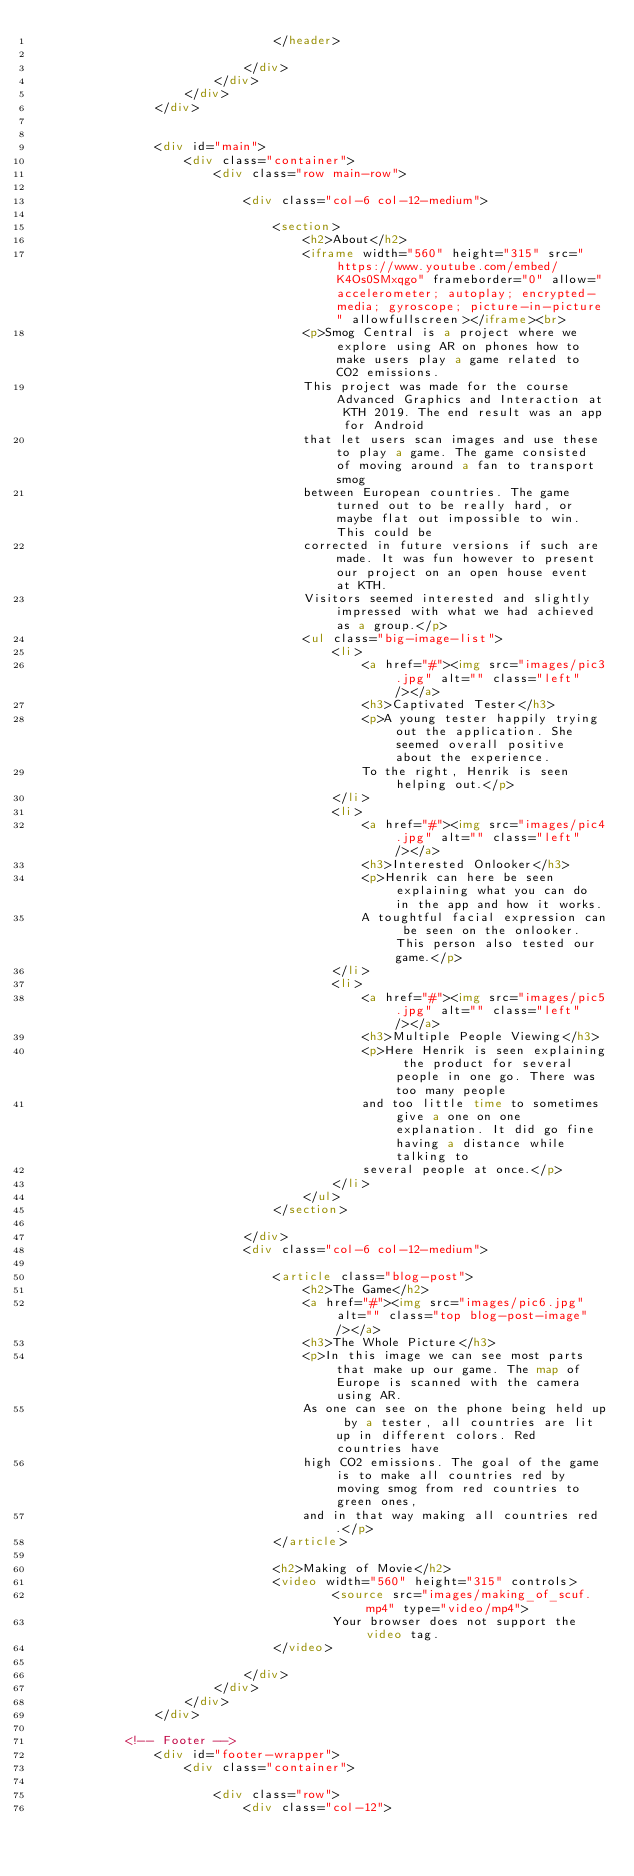Convert code to text. <code><loc_0><loc_0><loc_500><loc_500><_HTML_>								</header>

							</div>
						</div>
					</div>
				</div>


				<div id="main">
					<div class="container">
						<div class="row main-row">

							<div class="col-6 col-12-medium">

								<section>
									<h2>About</h2>
									<iframe width="560" height="315" src="https://www.youtube.com/embed/K4Os0SMxqgo" frameborder="0" allow="accelerometer; autoplay; encrypted-media; gyroscope; picture-in-picture" allowfullscreen></iframe><br>
									<p>Smog Central is a project where we explore using AR on phones how to make users play a game related to CO2 emissions.
									This project was made for the course Advanced Graphics and Interaction at KTH 2019. The end result was an app for Android
									that let users scan images and use these to play a game. The game consisted of moving around a fan to transport smog
									between European countries. The game turned out to be really hard, or maybe flat out impossible to win. This could be
									corrected in future versions if such are made. It was fun however to present our project on an open house event at KTH.
									Visitors seemed interested and slightly impressed with what we had achieved as a group.</p>
									<ul class="big-image-list">
										<li>
											<a href="#"><img src="images/pic3.jpg" alt="" class="left" /></a>
											<h3>Captivated Tester</h3>
											<p>A young tester happily trying out the application. She seemed overall positive about the experience.
											To the right, Henrik is seen helping out.</p>
										</li>
										<li>
											<a href="#"><img src="images/pic4.jpg" alt="" class="left" /></a>
											<h3>Interested Onlooker</h3>
											<p>Henrik can here be seen explaining what you can do in the app and how it works.
											A toughtful facial expression can be seen on the onlooker. This person also tested our game.</p>
										</li>
										<li>
											<a href="#"><img src="images/pic5.jpg" alt="" class="left" /></a>
											<h3>Multiple People Viewing</h3>
											<p>Here Henrik is seen explaining the product for several people in one go. There was too many people
											and too little time to sometimes give a one on one explanation. It did go fine having a distance while talking to
											several people at once.</p>
										</li>
									</ul>
								</section>

							</div>
							<div class="col-6 col-12-medium">

								<article class="blog-post">
									<h2>The Game</h2>
									<a href="#"><img src="images/pic6.jpg" alt="" class="top blog-post-image" /></a>
									<h3>The Whole Picture</h3>
									<p>In this image we can see most parts that make up our game. The map of Europe is scanned with the camera using AR.
									As one can see on the phone being held up by a tester, all countries are lit up in different colors. Red countries have
									high CO2 emissions. The goal of the game is to make all countries red by moving smog from red countries to green ones,
									and in that way making all countries red.</p>
								</article>

								<h2>Making of Movie</h2>
								<video width="560" height="315" controls>
										<source src="images/making_of_scuf.mp4" type="video/mp4">
										Your browser does not support the video tag.
								</video>

							</div>
						</div>
					</div>
				</div>

			<!-- Footer -->
				<div id="footer-wrapper">
					<div class="container">

						<div class="row">
							<div class="col-12">
</code> 